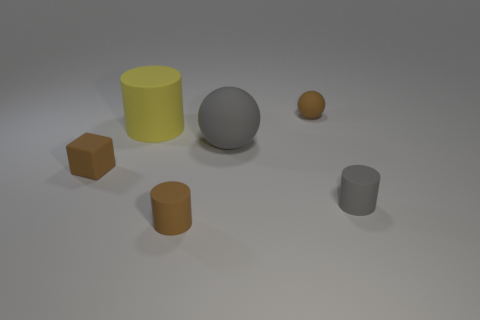Subtract 1 cylinders. How many cylinders are left? 2 Add 3 yellow matte cylinders. How many objects exist? 9 Subtract all cubes. How many objects are left? 5 Add 1 yellow rubber things. How many yellow rubber things exist? 2 Subtract 0 cyan blocks. How many objects are left? 6 Subtract all brown shiny cubes. Subtract all blocks. How many objects are left? 5 Add 4 big yellow rubber objects. How many big yellow rubber objects are left? 5 